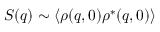<formula> <loc_0><loc_0><loc_500><loc_500>S ( q ) \sim \langle \rho ( q , 0 ) \rho ^ { \ast } ( q , 0 ) \rangle</formula> 